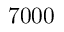<formula> <loc_0><loc_0><loc_500><loc_500>7 0 0 0</formula> 